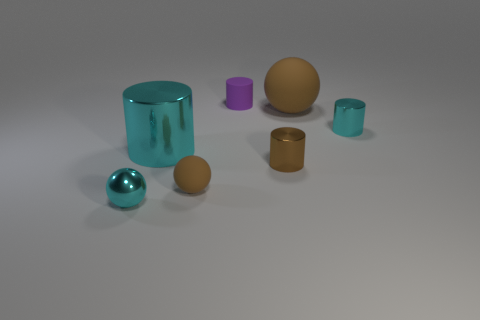Can you tell me more about the textures of the objects in this image? Certainly! In this image, you can see objects with what looks like smooth, shiny surfaces, such as the teal-blue sphere and cylinder, as well as others with matte finishes, like the golden cylinder and the mustard-brown sphere. How would you describe the lighting in the scene? The lighting appears to be soft and diffused, suggesting an indoor setting with well-distributed light, possibly from overhead sources. This results in gentle shadows and a calm atmosphere. 